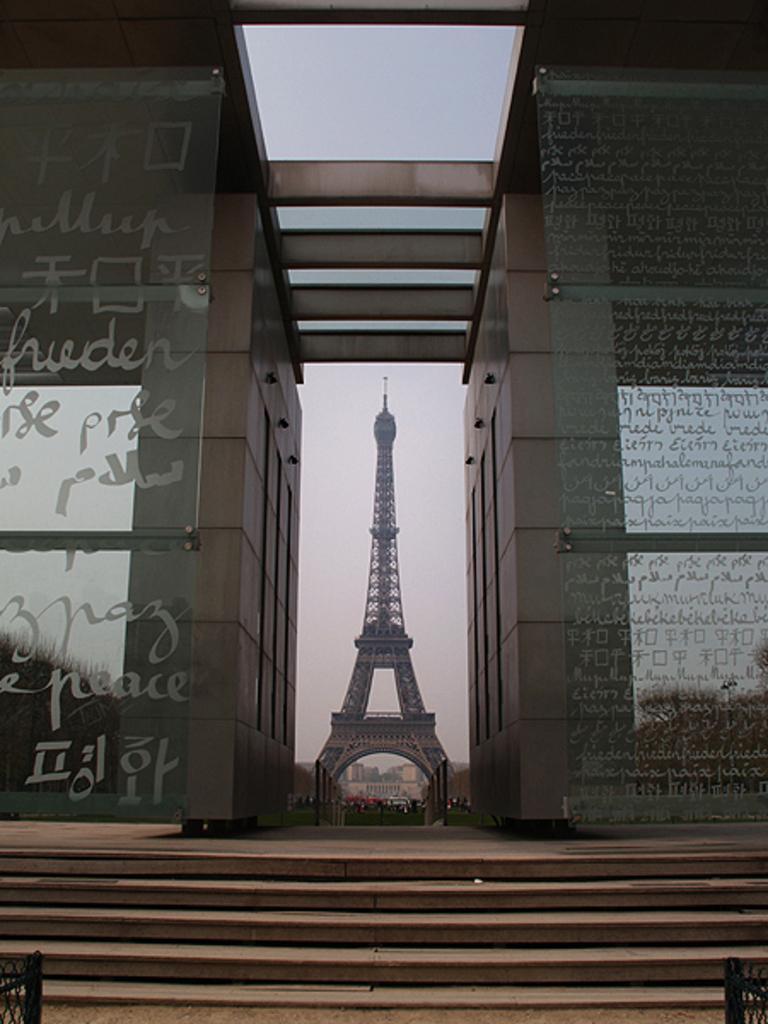How would you summarize this image in a sentence or two? On the right side and left side there are glass walls, at the bottom there are stairs, in the middle there is a tower, in the background there is the sky. 